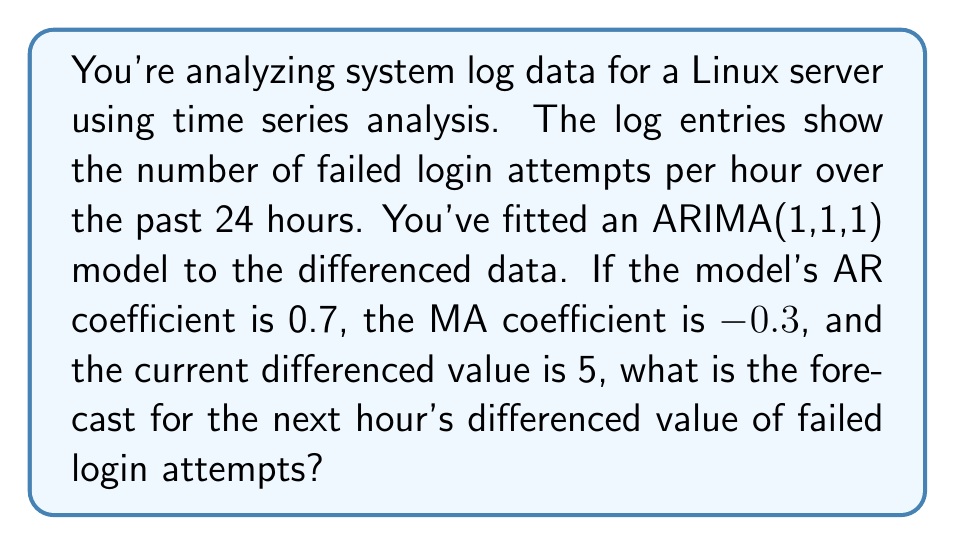Can you answer this question? Let's approach this step-by-step:

1) The ARIMA(1,1,1) model for differenced data can be written as:

   $$y_t = c + \phi_1 y_{t-1} + \theta_1 \epsilon_{t-1} + \epsilon_t$$

   Where:
   - $y_t$ is the differenced value at time $t$
   - $c$ is the constant (often assumed to be 0 for differenced data)
   - $\phi_1$ is the AR coefficient
   - $\theta_1$ is the MA coefficient
   - $\epsilon_t$ is the error term at time $t$

2) Given:
   - AR coefficient $\phi_1 = 0.7$
   - MA coefficient $\theta_1 = -0.3$
   - Current differenced value $y_t = 5$

3) To forecast the next value, we use:

   $$\hat{y}_{t+1} = c + \phi_1 y_t + \theta_1 \epsilon_t$$

4) We don't know the current error term $\epsilon_t$, but in forecasting, we typically set unknown future errors to their expected value of 0.

5) Assuming $c = 0$ for differenced data, we can calculate:

   $$\hat{y}_{t+1} = 0 + 0.7 * 5 + (-0.3) * 0$$
   $$\hat{y}_{t+1} = 3.5$$

6) Therefore, the forecast for the next hour's differenced value of failed login attempts is 3.5.
Answer: 3.5 